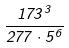Convert formula to latex. <formula><loc_0><loc_0><loc_500><loc_500>\frac { 1 7 3 ^ { 3 } } { 2 7 7 \cdot 5 ^ { 6 } }</formula> 